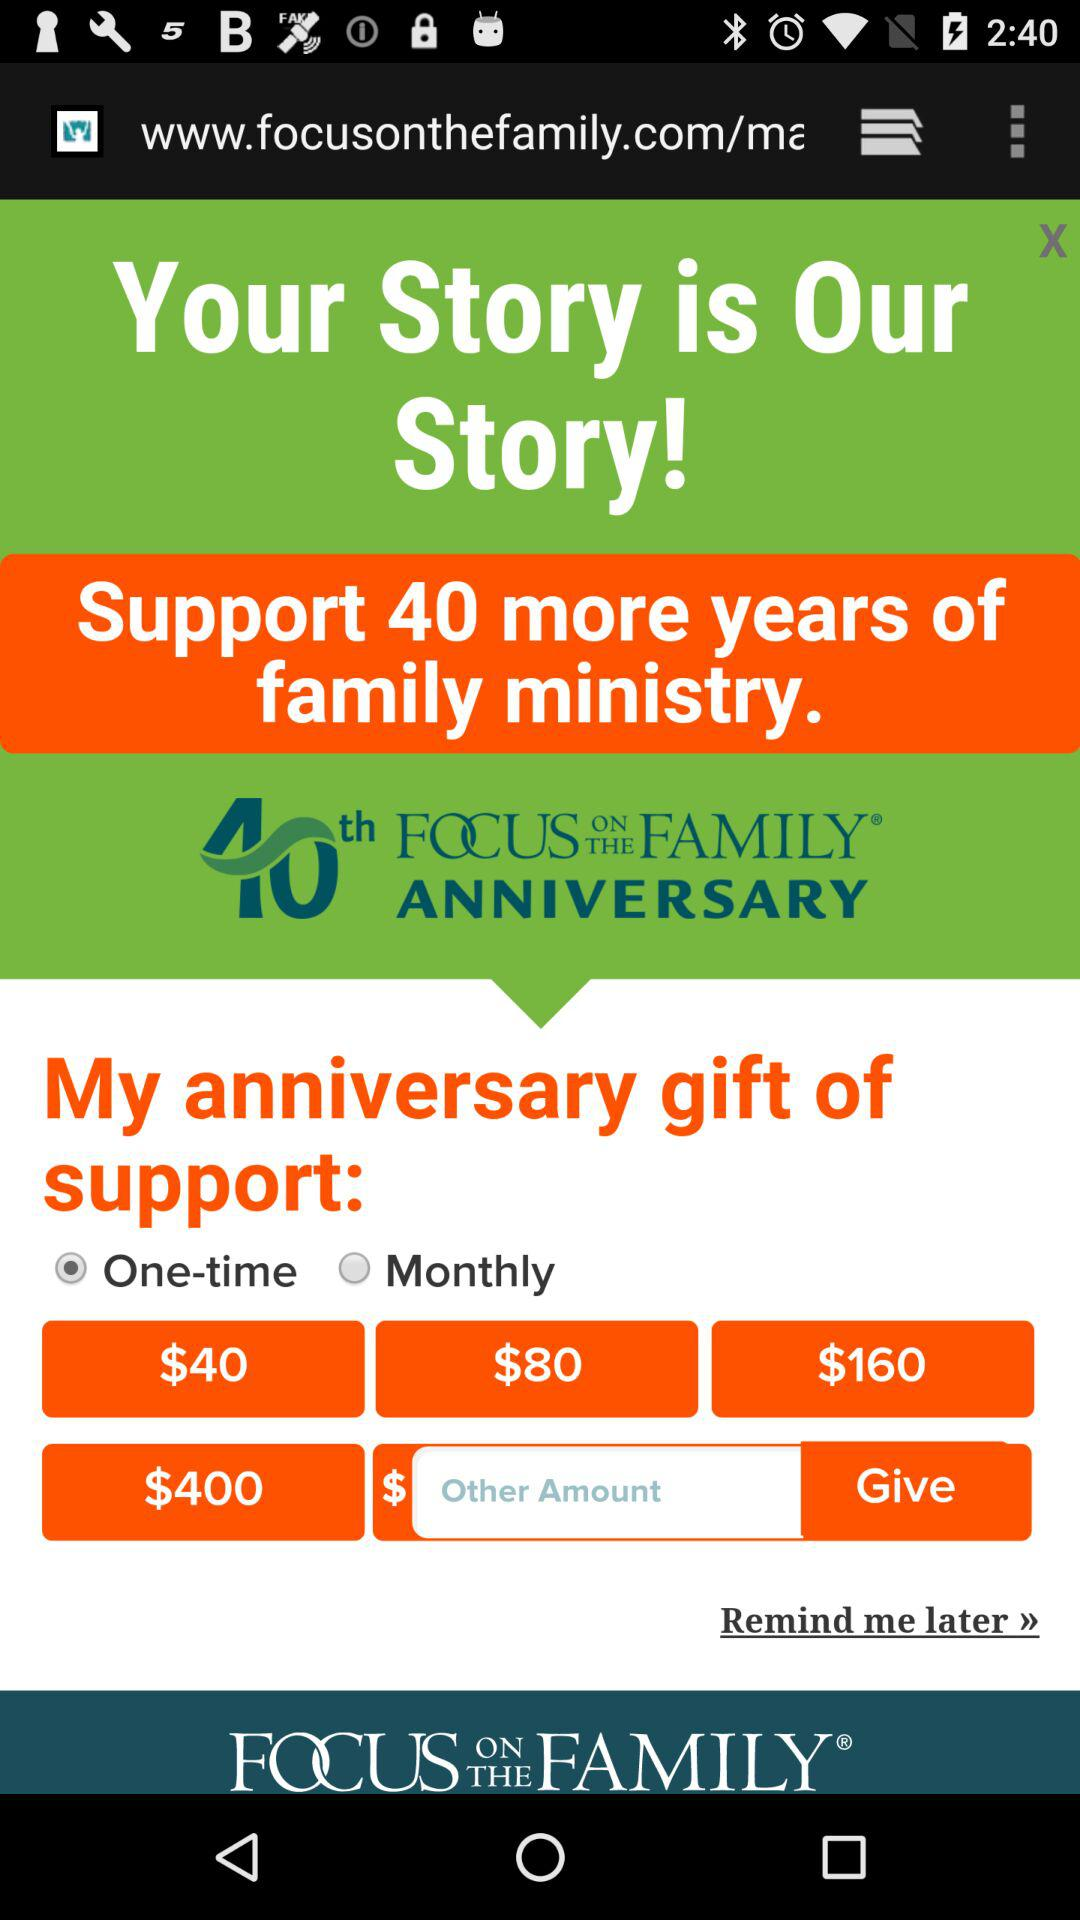Which option is selected? The selected option is "One-time". 